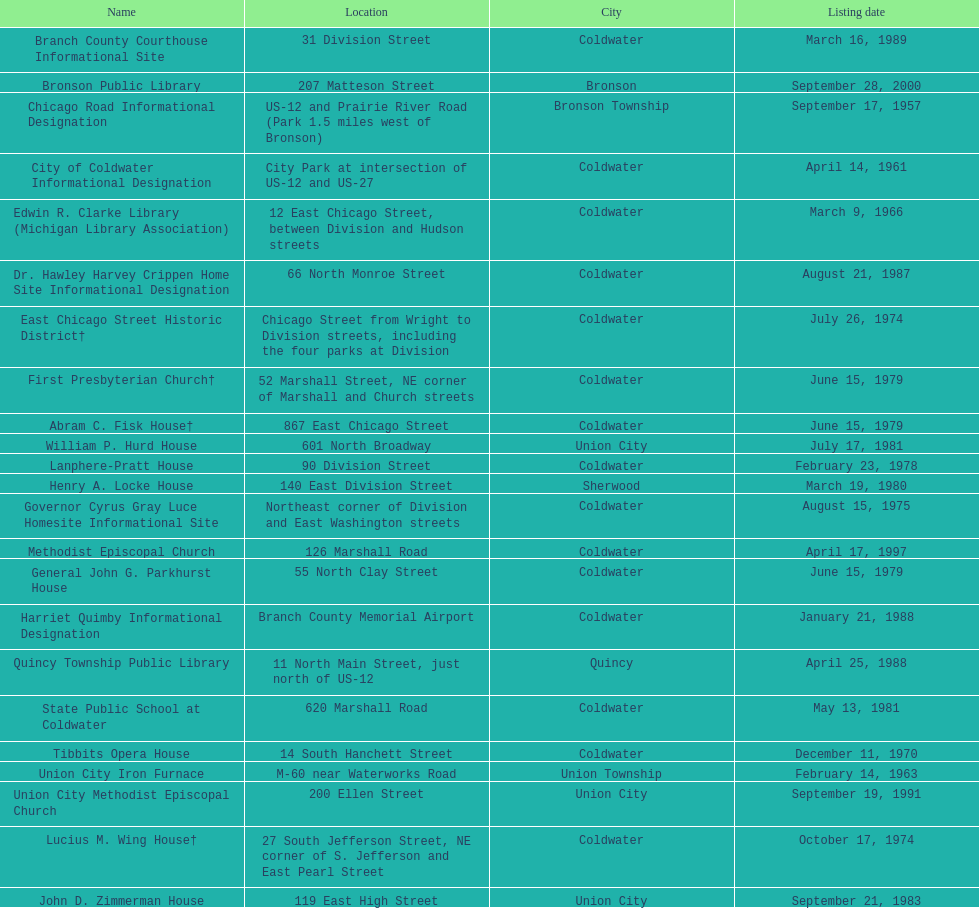How many historic landmarks were registered in 1988? 2. 